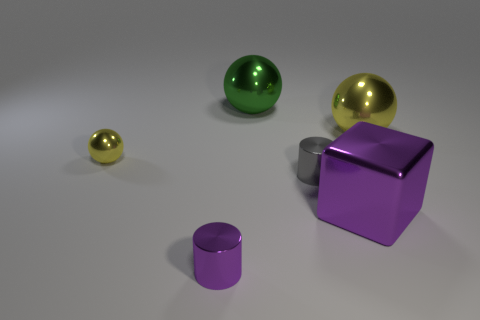Subtract all large spheres. How many spheres are left? 1 Subtract all cyan cylinders. How many yellow spheres are left? 2 Subtract all green balls. How many balls are left? 2 Subtract all brown balls. Subtract all green cubes. How many balls are left? 3 Subtract all cubes. How many objects are left? 5 Add 3 small green cylinders. How many objects exist? 9 Subtract all big metal things. Subtract all yellow shiny things. How many objects are left? 1 Add 5 purple cubes. How many purple cubes are left? 6 Add 4 big purple shiny blocks. How many big purple shiny blocks exist? 5 Subtract 0 red cylinders. How many objects are left? 6 